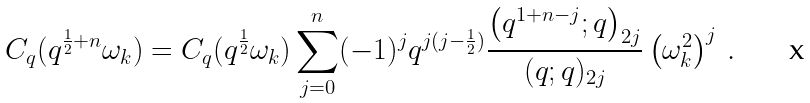<formula> <loc_0><loc_0><loc_500><loc_500>C _ { q } ( q ^ { \frac { 1 } { 2 } + n } \omega _ { k } ) = C _ { q } ( q ^ { \frac { 1 } { 2 } } \omega _ { k } ) \sum _ { j = 0 } ^ { n } ( - 1 ) ^ { j } q ^ { j ( j - \frac { 1 } { 2 } ) } \frac { \left ( q ^ { 1 + n - j } ; q \right ) _ { 2 j } } { ( q ; q ) _ { 2 j } } \left ( \omega _ { k } ^ { 2 } \right ) ^ { j } \, .</formula> 